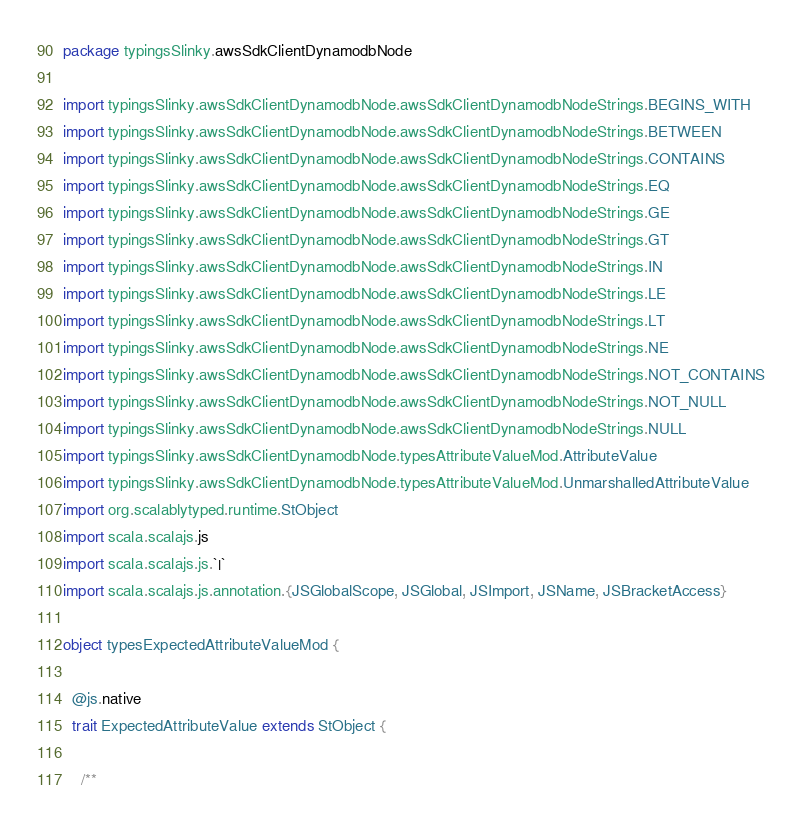<code> <loc_0><loc_0><loc_500><loc_500><_Scala_>package typingsSlinky.awsSdkClientDynamodbNode

import typingsSlinky.awsSdkClientDynamodbNode.awsSdkClientDynamodbNodeStrings.BEGINS_WITH
import typingsSlinky.awsSdkClientDynamodbNode.awsSdkClientDynamodbNodeStrings.BETWEEN
import typingsSlinky.awsSdkClientDynamodbNode.awsSdkClientDynamodbNodeStrings.CONTAINS
import typingsSlinky.awsSdkClientDynamodbNode.awsSdkClientDynamodbNodeStrings.EQ
import typingsSlinky.awsSdkClientDynamodbNode.awsSdkClientDynamodbNodeStrings.GE
import typingsSlinky.awsSdkClientDynamodbNode.awsSdkClientDynamodbNodeStrings.GT
import typingsSlinky.awsSdkClientDynamodbNode.awsSdkClientDynamodbNodeStrings.IN
import typingsSlinky.awsSdkClientDynamodbNode.awsSdkClientDynamodbNodeStrings.LE
import typingsSlinky.awsSdkClientDynamodbNode.awsSdkClientDynamodbNodeStrings.LT
import typingsSlinky.awsSdkClientDynamodbNode.awsSdkClientDynamodbNodeStrings.NE
import typingsSlinky.awsSdkClientDynamodbNode.awsSdkClientDynamodbNodeStrings.NOT_CONTAINS
import typingsSlinky.awsSdkClientDynamodbNode.awsSdkClientDynamodbNodeStrings.NOT_NULL
import typingsSlinky.awsSdkClientDynamodbNode.awsSdkClientDynamodbNodeStrings.NULL
import typingsSlinky.awsSdkClientDynamodbNode.typesAttributeValueMod.AttributeValue
import typingsSlinky.awsSdkClientDynamodbNode.typesAttributeValueMod.UnmarshalledAttributeValue
import org.scalablytyped.runtime.StObject
import scala.scalajs.js
import scala.scalajs.js.`|`
import scala.scalajs.js.annotation.{JSGlobalScope, JSGlobal, JSImport, JSName, JSBracketAccess}

object typesExpectedAttributeValueMod {
  
  @js.native
  trait ExpectedAttributeValue extends StObject {
    
    /**</code> 